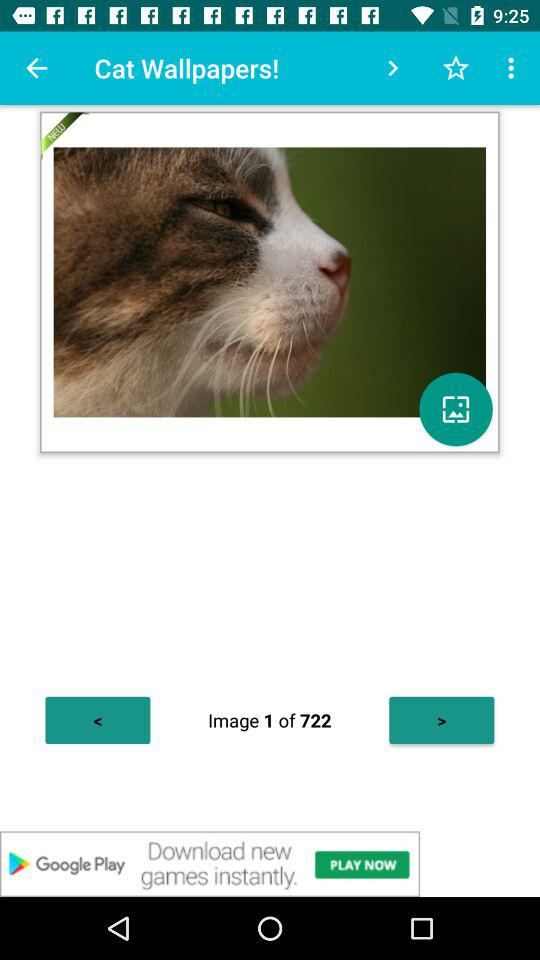How many images are there in "Cat Wallpapers!"? There are 722 images. 